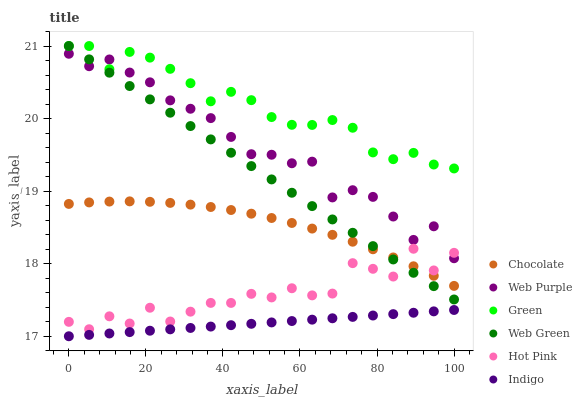Does Indigo have the minimum area under the curve?
Answer yes or no. Yes. Does Green have the maximum area under the curve?
Answer yes or no. Yes. Does Hot Pink have the minimum area under the curve?
Answer yes or no. No. Does Hot Pink have the maximum area under the curve?
Answer yes or no. No. Is Web Green the smoothest?
Answer yes or no. Yes. Is Hot Pink the roughest?
Answer yes or no. Yes. Is Hot Pink the smoothest?
Answer yes or no. No. Is Web Green the roughest?
Answer yes or no. No. Does Indigo have the lowest value?
Answer yes or no. Yes. Does Hot Pink have the lowest value?
Answer yes or no. No. Does Green have the highest value?
Answer yes or no. Yes. Does Hot Pink have the highest value?
Answer yes or no. No. Is Chocolate less than Green?
Answer yes or no. Yes. Is Web Purple greater than Indigo?
Answer yes or no. Yes. Does Web Purple intersect Green?
Answer yes or no. Yes. Is Web Purple less than Green?
Answer yes or no. No. Is Web Purple greater than Green?
Answer yes or no. No. Does Chocolate intersect Green?
Answer yes or no. No. 